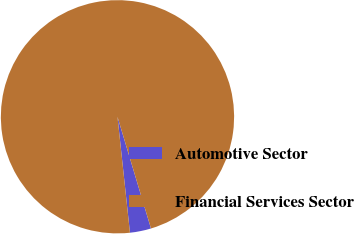<chart> <loc_0><loc_0><loc_500><loc_500><pie_chart><fcel>Automotive Sector<fcel>Financial Services Sector<nl><fcel>2.93%<fcel>97.07%<nl></chart> 